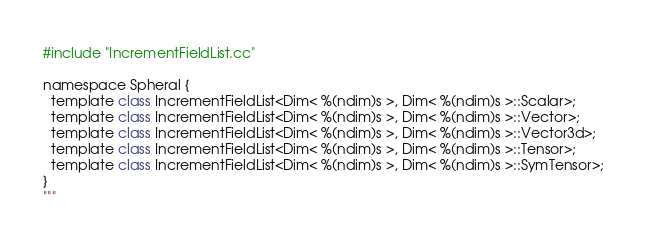Convert code to text. <code><loc_0><loc_0><loc_500><loc_500><_Python_>#include "IncrementFieldList.cc"

namespace Spheral {
  template class IncrementFieldList<Dim< %(ndim)s >, Dim< %(ndim)s >::Scalar>;
  template class IncrementFieldList<Dim< %(ndim)s >, Dim< %(ndim)s >::Vector>;
  template class IncrementFieldList<Dim< %(ndim)s >, Dim< %(ndim)s >::Vector3d>;
  template class IncrementFieldList<Dim< %(ndim)s >, Dim< %(ndim)s >::Tensor>;
  template class IncrementFieldList<Dim< %(ndim)s >, Dim< %(ndim)s >::SymTensor>;
}
"""
</code> 